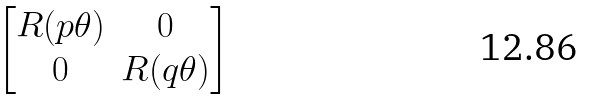<formula> <loc_0><loc_0><loc_500><loc_500>\begin{bmatrix} R ( p \theta ) & 0 \\ 0 & R ( q \theta ) \end{bmatrix}</formula> 